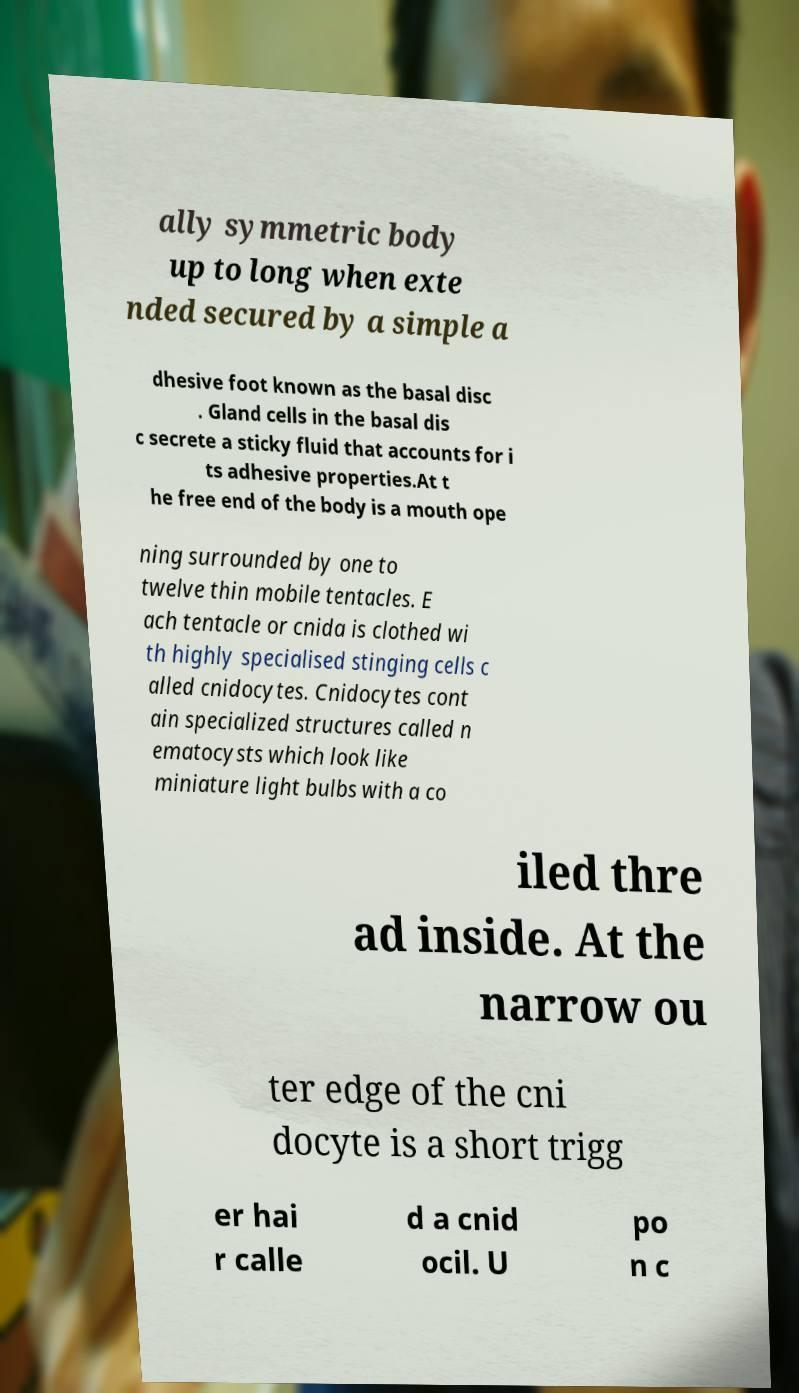Can you accurately transcribe the text from the provided image for me? ally symmetric body up to long when exte nded secured by a simple a dhesive foot known as the basal disc . Gland cells in the basal dis c secrete a sticky fluid that accounts for i ts adhesive properties.At t he free end of the body is a mouth ope ning surrounded by one to twelve thin mobile tentacles. E ach tentacle or cnida is clothed wi th highly specialised stinging cells c alled cnidocytes. Cnidocytes cont ain specialized structures called n ematocysts which look like miniature light bulbs with a co iled thre ad inside. At the narrow ou ter edge of the cni docyte is a short trigg er hai r calle d a cnid ocil. U po n c 